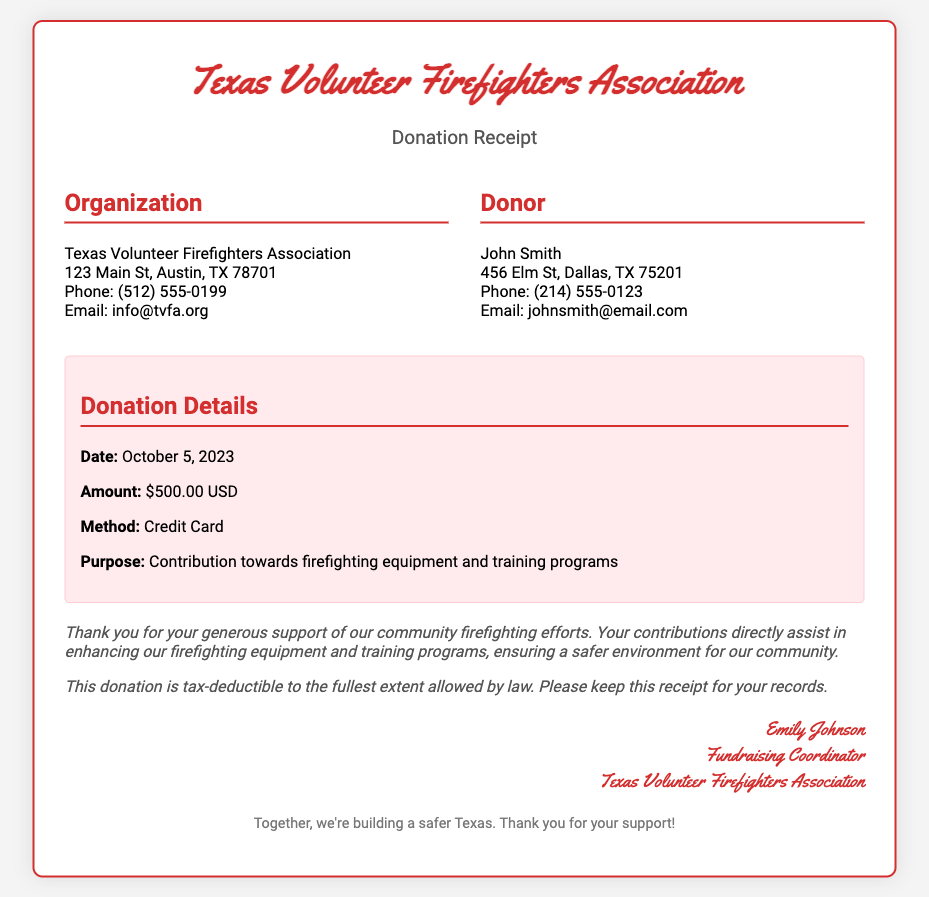what is the name of the organization? The organization's name is listed at the top of the document in the header section.
Answer: Texas Volunteer Firefighters Association who is the donor? The donor's name is indicated in the "Donor" section of the document.
Answer: John Smith what was the donation amount? The donation amount is specified in the "Donation Details" section.
Answer: $500.00 USD when was the donation made? The date of the donation is provided in the "Donation Details" section.
Answer: October 5, 2023 what is the purpose of the donation? The purpose of the donation is outlined in the "Donation Details" section.
Answer: Contribution towards firefighting equipment and training programs who signed the receipt? The signature section includes the name of the individual who signed the receipt.
Answer: Emily Johnson how is the donation recognized for tax purposes? The acknowledgment section provides information regarding tax deductibility of the donation.
Answer: Tax-deductible what is the main message in the acknowledgment section? The acknowledgment section thanks the donor and emphasizes the impact of the donation.
Answer: Thank you for your generous support what contact method is provided for the organization? The organization’s contact information includes a phone number listed in the document.
Answer: Phone: (512) 555-0199 